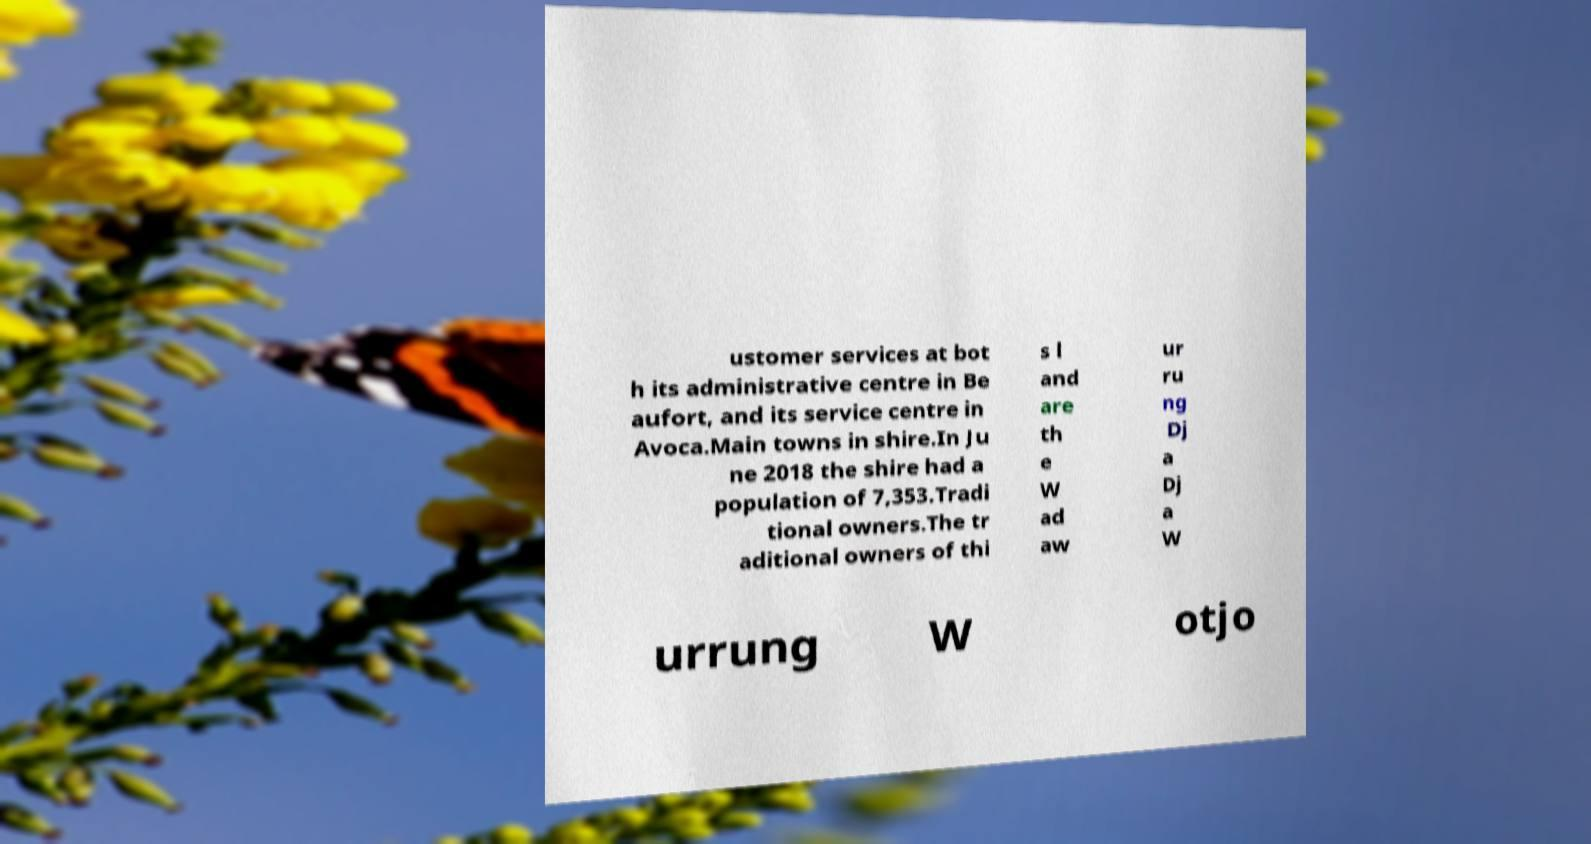There's text embedded in this image that I need extracted. Can you transcribe it verbatim? ustomer services at bot h its administrative centre in Be aufort, and its service centre in Avoca.Main towns in shire.In Ju ne 2018 the shire had a population of 7,353.Tradi tional owners.The tr aditional owners of thi s l and are th e W ad aw ur ru ng Dj a Dj a W urrung W otjo 